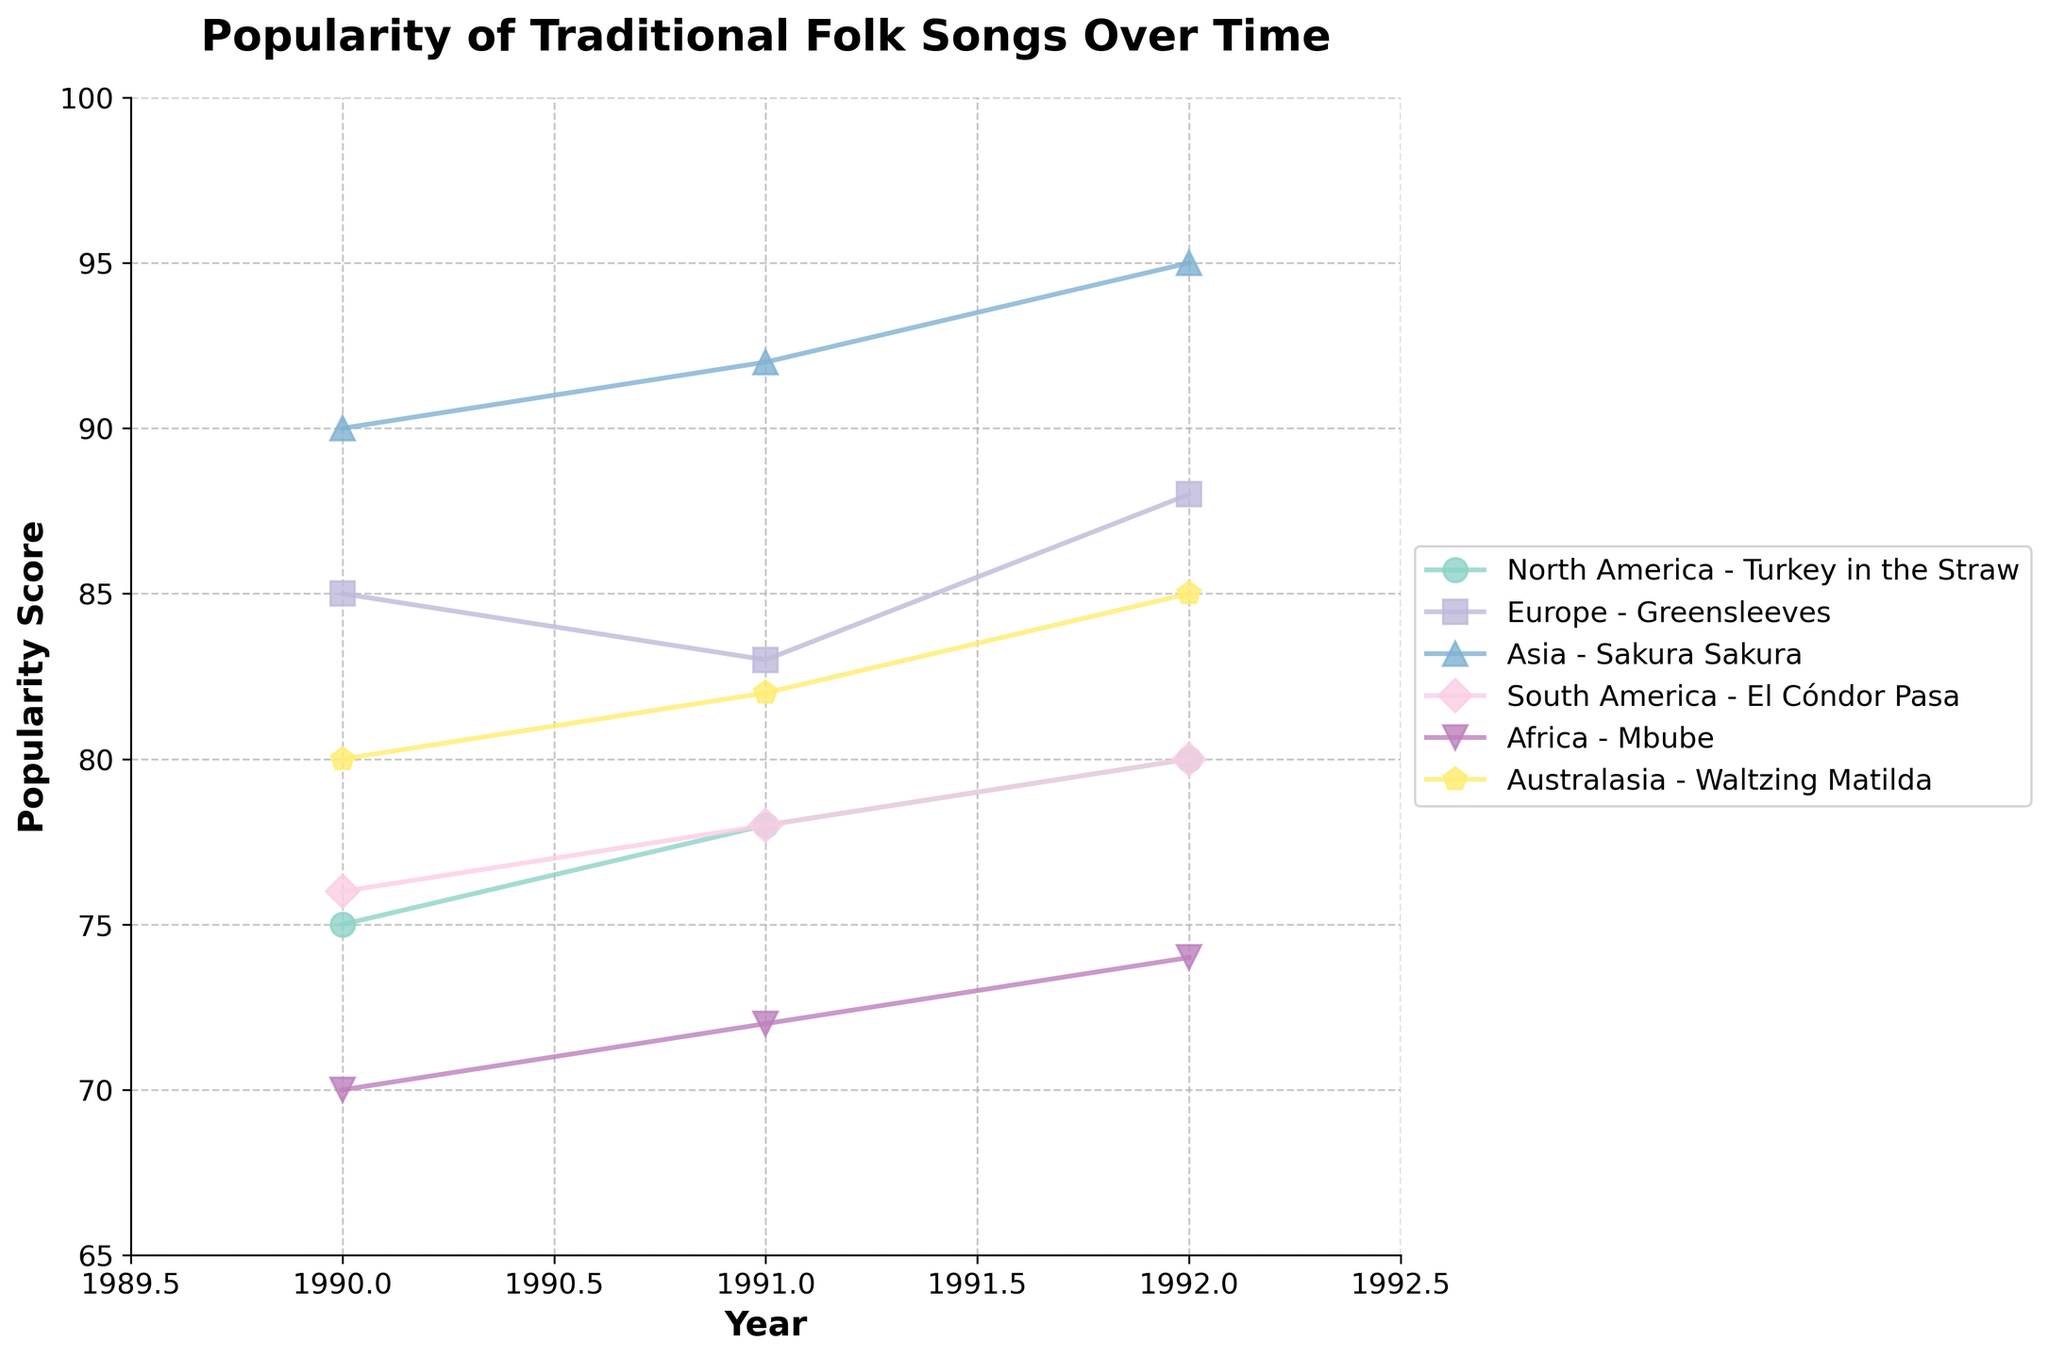What is the title of the plot? The title of the plot is usually found at the top of the figure. In this case, it reads "Popularity of Traditional Folk Songs Over Time".
Answer: Popularity of Traditional Folk Songs Over Time Which region has the song with the highest popularity score in 1990? According to the plot, the axis starting from 1990 should show the highest data point among all the regions. 'Asia' scores the highest in 1990 with "Sakura Sakura" at 90.
Answer: Asia How does the popularity score of "El Cóndor Pasa" change from 1990 to 1992? We follow the line representing South America from 1990 to 1992. It shows the popularity score increasing from 76 in 1990 to 80 in 1992.
Answer: It increases Which song in Australasia had the highest popularity score in 1992? By looking at 1992 on the x-axis and tracing the data point for Australasia, we see that "Waltzing Matilda" has a score of 85, the highest for that song in the period shown.
Answer: Waltzing Matilda Between Europe and North America, which region’s song had a higher popularity score in 1991? Referencing 1991, the plot shows "Greensleeves" in Europe at 83 and "Turkey in the Straw" in North America at 78. Hence, Europe's song had a higher score.
Answer: Europe What is the average popularity score for "Mbube" from 1990 to 1992? First, sum the score values of "Mbube" in Africa from 1990 to 1992: 70 + 72 + 74 = 216. Then, divide by 3 years: 216/3 = 72.
Answer: 72 Which region shows a consistent increase in popularity scores every year from 1990 to 1992? By examining each region's trend line, Asia with "Sakura Sakura" consistently increases each year (90, 92, 95).
Answer: Asia Compare the popularity scores of "Sakura Sakura" and "El Cóndor Pasa" in 1990. Which one is higher? In 1990, "Sakura Sakura" in Asia scores 90, while "El Cóndor Pasa" in South America scores 76. Hence, "Sakura Sakura" scores higher.
Answer: Sakura Sakura What is the range of the popularity scores for "Waltzing Matilda" from 1990 to 1992? The range is calculated by subtracting the lowest score from the highest score within the period. “Waltzing Matilda” ranges from 80 to 85: 85 - 80 = 5.
Answer: 5 What trend can be observed for the song "Greensleeves" in Europe from 1990 to 1992? Observing the plot line for "Greensleeves" in Europe reveals it drops from 85 in 1990 to 83 in 1991, then rises to 88 in 1992.
Answer: Drops then rises 